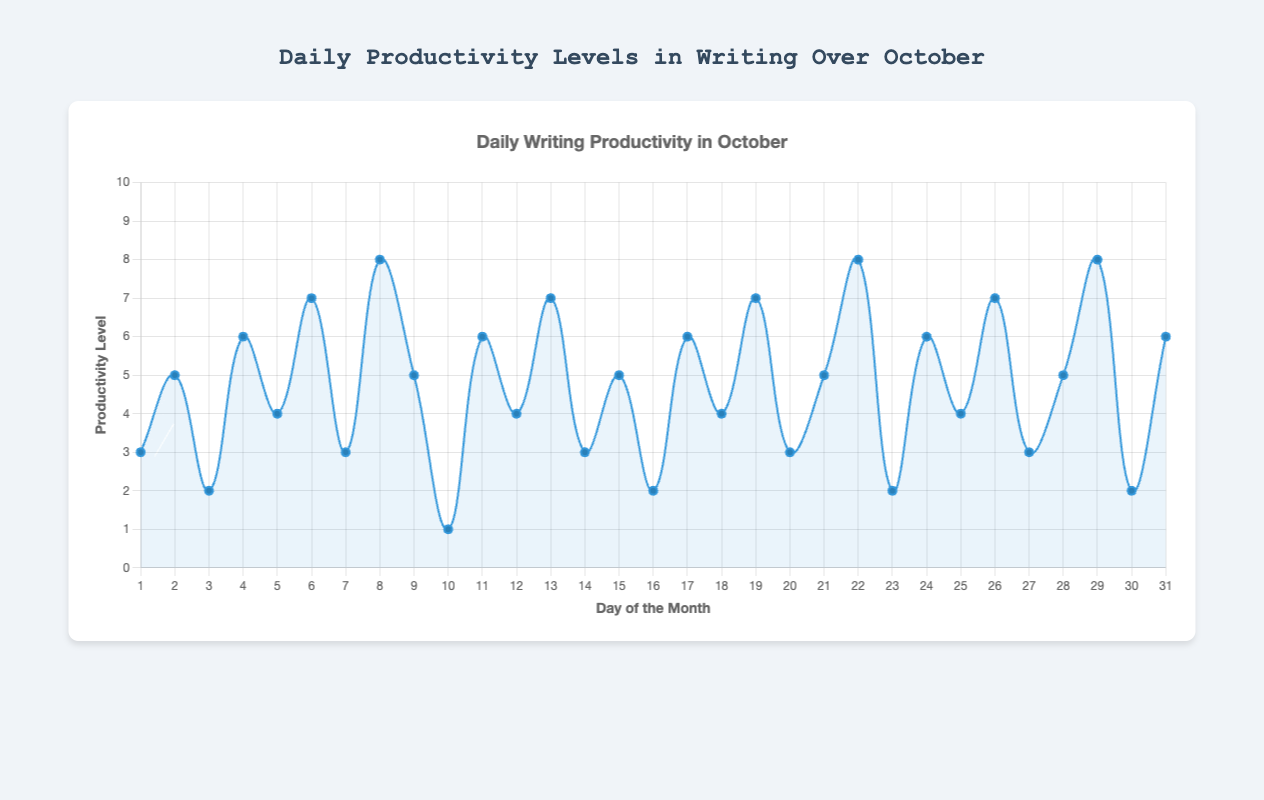What is the peak productivity level of the month? Observing the highest point on the productivity curve, you can see that the peak productivity level is 8.
Answer: 8 How does the productivity level on day 10 compare to day 29? On day 10, the productivity level is at its lowest point, which is 1. On day 29, it reaches a high of 8. Therefore, the productivity level on day 29 is significantly higher than on day 10.
Answer: Day 29 is higher What is the total productivity level for the first week of October? Summing up the productivity levels from day 1 to day 7: 3 + 5 + 2 + 6 + 4 + 7 + 3 = 30.
Answer: 30 What is the average productivity level for the second week of October (day 8 to day 14)? The productivity levels from day 8 to day 14 are: 8, 5, 1, 6, 4, 7, 3. Adding these gives 34. The average is 34 divided by 7, which equals approximately 4.86.
Answer: 4.86 Which day(s) had the lowest productivity level, and what was the main reason based on the notes? The lowest productivity level is 1 on day 10. Referring to the notes, the main reason was "Faced several personal interruptions”.
Answer: Day 10, personal interruptions What is the difference in productivity levels between day 22 and day 25? The productivity level on day 22 is 8 and on day 25 is 4. The difference is 8 - 4 = 4.
Answer: 4 Which locations had the most consistently high productivity levels? By observing the locations and their corresponding productivity levels, it appears that days spent writing in the "Home Office" and "Library" generally have higher productivity levels, with multiple instances of productivity scores of 6 and above.
Answer: Home Office and Library How does writing in the Library compare to writing in the Home Office in terms of average productivity levels? Calculating the average productivity level for each location: Home Office: (3 + 2 + 6 + 8 + 7 + 5 + 6 + 7 + 4 + 2 + 6 + 8 + 3) / 13 = 5; Library: (7 + 3 + 4 + 6 + 7 + 8 + 6) / 7 = ~5.86. The Library's average is slightly higher.
Answer: Library slightly higher What is the trend in productivity over the month; does it generally increase, decrease, or remain stable? Observing the general pattern of the productivity curve, it shows fluctuations but no consistent increase or decrease. Rather, it seems to have periods of low, moderate, and high productivity randomly scattered throughout.
Answer: Fluctuates 